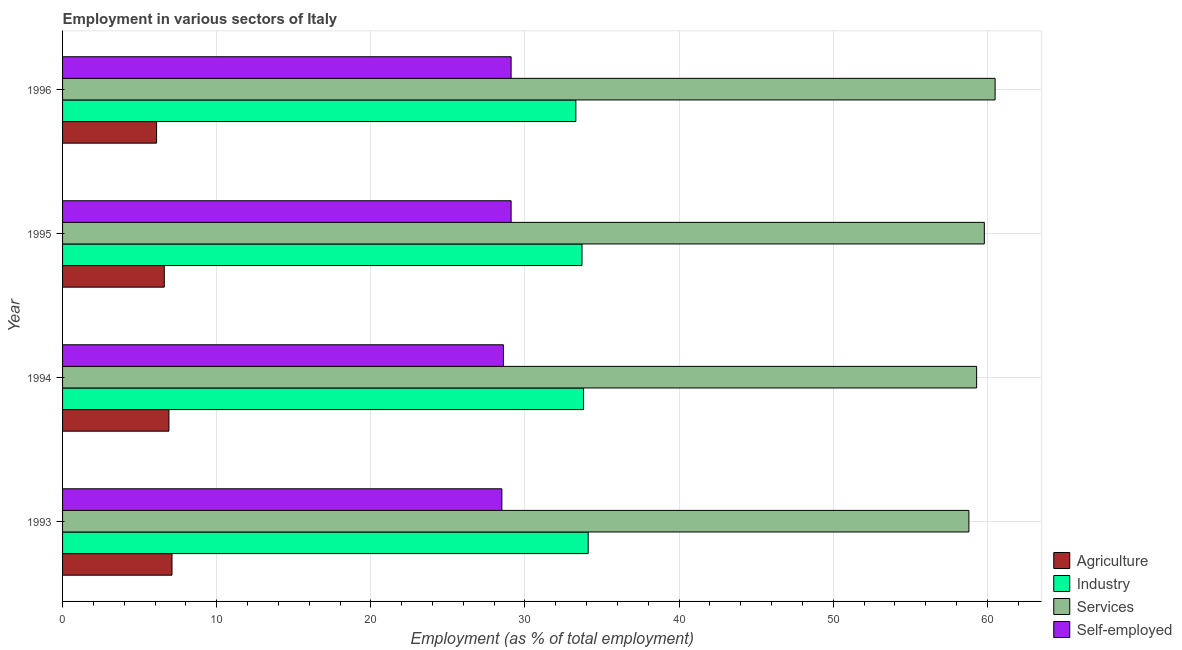How many bars are there on the 4th tick from the top?
Offer a very short reply. 4. How many bars are there on the 1st tick from the bottom?
Ensure brevity in your answer.  4. What is the label of the 2nd group of bars from the top?
Your answer should be compact. 1995. What is the percentage of workers in services in 1993?
Offer a terse response. 58.8. Across all years, what is the maximum percentage of workers in services?
Your answer should be very brief. 60.5. Across all years, what is the minimum percentage of self employed workers?
Provide a succinct answer. 28.5. In which year was the percentage of workers in industry maximum?
Give a very brief answer. 1993. What is the total percentage of workers in agriculture in the graph?
Your answer should be very brief. 26.7. What is the difference between the percentage of workers in services in 1995 and the percentage of workers in agriculture in 1993?
Offer a terse response. 52.7. What is the average percentage of self employed workers per year?
Make the answer very short. 28.82. In the year 1993, what is the difference between the percentage of workers in industry and percentage of self employed workers?
Give a very brief answer. 5.6. In how many years, is the percentage of workers in services greater than 38 %?
Your answer should be very brief. 4. What is the ratio of the percentage of workers in industry in 1993 to that in 1995?
Your answer should be compact. 1.01. Is the percentage of self employed workers in 1993 less than that in 1994?
Make the answer very short. Yes. Is the difference between the percentage of workers in agriculture in 1995 and 1996 greater than the difference between the percentage of workers in industry in 1995 and 1996?
Your answer should be compact. Yes. What is the difference between the highest and the second highest percentage of workers in services?
Offer a terse response. 0.7. What is the difference between the highest and the lowest percentage of workers in industry?
Ensure brevity in your answer.  0.8. Is the sum of the percentage of self employed workers in 1993 and 1994 greater than the maximum percentage of workers in agriculture across all years?
Provide a short and direct response. Yes. What does the 2nd bar from the top in 1995 represents?
Keep it short and to the point. Services. What does the 3rd bar from the bottom in 1995 represents?
Your response must be concise. Services. How many bars are there?
Provide a succinct answer. 16. How many years are there in the graph?
Your answer should be compact. 4. What is the difference between two consecutive major ticks on the X-axis?
Give a very brief answer. 10. Are the values on the major ticks of X-axis written in scientific E-notation?
Keep it short and to the point. No. Does the graph contain grids?
Your answer should be compact. Yes. How many legend labels are there?
Provide a short and direct response. 4. How are the legend labels stacked?
Offer a very short reply. Vertical. What is the title of the graph?
Offer a very short reply. Employment in various sectors of Italy. What is the label or title of the X-axis?
Keep it short and to the point. Employment (as % of total employment). What is the label or title of the Y-axis?
Keep it short and to the point. Year. What is the Employment (as % of total employment) in Agriculture in 1993?
Make the answer very short. 7.1. What is the Employment (as % of total employment) in Industry in 1993?
Your answer should be compact. 34.1. What is the Employment (as % of total employment) in Services in 1993?
Your response must be concise. 58.8. What is the Employment (as % of total employment) of Self-employed in 1993?
Your answer should be very brief. 28.5. What is the Employment (as % of total employment) in Agriculture in 1994?
Your answer should be compact. 6.9. What is the Employment (as % of total employment) in Industry in 1994?
Your answer should be very brief. 33.8. What is the Employment (as % of total employment) of Services in 1994?
Provide a short and direct response. 59.3. What is the Employment (as % of total employment) of Self-employed in 1994?
Provide a succinct answer. 28.6. What is the Employment (as % of total employment) of Agriculture in 1995?
Your response must be concise. 6.6. What is the Employment (as % of total employment) of Industry in 1995?
Your answer should be compact. 33.7. What is the Employment (as % of total employment) of Services in 1995?
Your answer should be compact. 59.8. What is the Employment (as % of total employment) in Self-employed in 1995?
Your answer should be very brief. 29.1. What is the Employment (as % of total employment) of Agriculture in 1996?
Give a very brief answer. 6.1. What is the Employment (as % of total employment) in Industry in 1996?
Give a very brief answer. 33.3. What is the Employment (as % of total employment) of Services in 1996?
Ensure brevity in your answer.  60.5. What is the Employment (as % of total employment) in Self-employed in 1996?
Keep it short and to the point. 29.1. Across all years, what is the maximum Employment (as % of total employment) in Agriculture?
Keep it short and to the point. 7.1. Across all years, what is the maximum Employment (as % of total employment) in Industry?
Offer a terse response. 34.1. Across all years, what is the maximum Employment (as % of total employment) in Services?
Provide a short and direct response. 60.5. Across all years, what is the maximum Employment (as % of total employment) in Self-employed?
Your response must be concise. 29.1. Across all years, what is the minimum Employment (as % of total employment) in Agriculture?
Your response must be concise. 6.1. Across all years, what is the minimum Employment (as % of total employment) of Industry?
Your response must be concise. 33.3. Across all years, what is the minimum Employment (as % of total employment) in Services?
Give a very brief answer. 58.8. What is the total Employment (as % of total employment) of Agriculture in the graph?
Offer a terse response. 26.7. What is the total Employment (as % of total employment) in Industry in the graph?
Your answer should be very brief. 134.9. What is the total Employment (as % of total employment) in Services in the graph?
Provide a succinct answer. 238.4. What is the total Employment (as % of total employment) in Self-employed in the graph?
Provide a short and direct response. 115.3. What is the difference between the Employment (as % of total employment) in Services in 1993 and that in 1994?
Provide a short and direct response. -0.5. What is the difference between the Employment (as % of total employment) of Services in 1993 and that in 1995?
Ensure brevity in your answer.  -1. What is the difference between the Employment (as % of total employment) in Self-employed in 1993 and that in 1995?
Ensure brevity in your answer.  -0.6. What is the difference between the Employment (as % of total employment) in Agriculture in 1993 and that in 1996?
Give a very brief answer. 1. What is the difference between the Employment (as % of total employment) in Industry in 1993 and that in 1996?
Your answer should be very brief. 0.8. What is the difference between the Employment (as % of total employment) of Services in 1993 and that in 1996?
Offer a very short reply. -1.7. What is the difference between the Employment (as % of total employment) in Self-employed in 1994 and that in 1995?
Your answer should be very brief. -0.5. What is the difference between the Employment (as % of total employment) in Services in 1994 and that in 1996?
Provide a succinct answer. -1.2. What is the difference between the Employment (as % of total employment) of Agriculture in 1995 and that in 1996?
Your response must be concise. 0.5. What is the difference between the Employment (as % of total employment) in Industry in 1995 and that in 1996?
Provide a short and direct response. 0.4. What is the difference between the Employment (as % of total employment) in Agriculture in 1993 and the Employment (as % of total employment) in Industry in 1994?
Offer a terse response. -26.7. What is the difference between the Employment (as % of total employment) in Agriculture in 1993 and the Employment (as % of total employment) in Services in 1994?
Provide a succinct answer. -52.2. What is the difference between the Employment (as % of total employment) in Agriculture in 1993 and the Employment (as % of total employment) in Self-employed in 1994?
Provide a short and direct response. -21.5. What is the difference between the Employment (as % of total employment) in Industry in 1993 and the Employment (as % of total employment) in Services in 1994?
Provide a short and direct response. -25.2. What is the difference between the Employment (as % of total employment) in Industry in 1993 and the Employment (as % of total employment) in Self-employed in 1994?
Make the answer very short. 5.5. What is the difference between the Employment (as % of total employment) of Services in 1993 and the Employment (as % of total employment) of Self-employed in 1994?
Offer a terse response. 30.2. What is the difference between the Employment (as % of total employment) in Agriculture in 1993 and the Employment (as % of total employment) in Industry in 1995?
Provide a succinct answer. -26.6. What is the difference between the Employment (as % of total employment) of Agriculture in 1993 and the Employment (as % of total employment) of Services in 1995?
Keep it short and to the point. -52.7. What is the difference between the Employment (as % of total employment) in Industry in 1993 and the Employment (as % of total employment) in Services in 1995?
Provide a short and direct response. -25.7. What is the difference between the Employment (as % of total employment) of Industry in 1993 and the Employment (as % of total employment) of Self-employed in 1995?
Provide a succinct answer. 5. What is the difference between the Employment (as % of total employment) of Services in 1993 and the Employment (as % of total employment) of Self-employed in 1995?
Give a very brief answer. 29.7. What is the difference between the Employment (as % of total employment) of Agriculture in 1993 and the Employment (as % of total employment) of Industry in 1996?
Ensure brevity in your answer.  -26.2. What is the difference between the Employment (as % of total employment) in Agriculture in 1993 and the Employment (as % of total employment) in Services in 1996?
Your response must be concise. -53.4. What is the difference between the Employment (as % of total employment) of Industry in 1993 and the Employment (as % of total employment) of Services in 1996?
Keep it short and to the point. -26.4. What is the difference between the Employment (as % of total employment) in Industry in 1993 and the Employment (as % of total employment) in Self-employed in 1996?
Offer a very short reply. 5. What is the difference between the Employment (as % of total employment) of Services in 1993 and the Employment (as % of total employment) of Self-employed in 1996?
Make the answer very short. 29.7. What is the difference between the Employment (as % of total employment) in Agriculture in 1994 and the Employment (as % of total employment) in Industry in 1995?
Your answer should be compact. -26.8. What is the difference between the Employment (as % of total employment) in Agriculture in 1994 and the Employment (as % of total employment) in Services in 1995?
Your answer should be very brief. -52.9. What is the difference between the Employment (as % of total employment) of Agriculture in 1994 and the Employment (as % of total employment) of Self-employed in 1995?
Your response must be concise. -22.2. What is the difference between the Employment (as % of total employment) in Industry in 1994 and the Employment (as % of total employment) in Services in 1995?
Make the answer very short. -26. What is the difference between the Employment (as % of total employment) in Industry in 1994 and the Employment (as % of total employment) in Self-employed in 1995?
Your answer should be very brief. 4.7. What is the difference between the Employment (as % of total employment) in Services in 1994 and the Employment (as % of total employment) in Self-employed in 1995?
Keep it short and to the point. 30.2. What is the difference between the Employment (as % of total employment) of Agriculture in 1994 and the Employment (as % of total employment) of Industry in 1996?
Your answer should be very brief. -26.4. What is the difference between the Employment (as % of total employment) of Agriculture in 1994 and the Employment (as % of total employment) of Services in 1996?
Keep it short and to the point. -53.6. What is the difference between the Employment (as % of total employment) of Agriculture in 1994 and the Employment (as % of total employment) of Self-employed in 1996?
Give a very brief answer. -22.2. What is the difference between the Employment (as % of total employment) of Industry in 1994 and the Employment (as % of total employment) of Services in 1996?
Your response must be concise. -26.7. What is the difference between the Employment (as % of total employment) of Services in 1994 and the Employment (as % of total employment) of Self-employed in 1996?
Your answer should be very brief. 30.2. What is the difference between the Employment (as % of total employment) in Agriculture in 1995 and the Employment (as % of total employment) in Industry in 1996?
Ensure brevity in your answer.  -26.7. What is the difference between the Employment (as % of total employment) in Agriculture in 1995 and the Employment (as % of total employment) in Services in 1996?
Offer a very short reply. -53.9. What is the difference between the Employment (as % of total employment) of Agriculture in 1995 and the Employment (as % of total employment) of Self-employed in 1996?
Ensure brevity in your answer.  -22.5. What is the difference between the Employment (as % of total employment) in Industry in 1995 and the Employment (as % of total employment) in Services in 1996?
Keep it short and to the point. -26.8. What is the difference between the Employment (as % of total employment) in Industry in 1995 and the Employment (as % of total employment) in Self-employed in 1996?
Your answer should be very brief. 4.6. What is the difference between the Employment (as % of total employment) in Services in 1995 and the Employment (as % of total employment) in Self-employed in 1996?
Ensure brevity in your answer.  30.7. What is the average Employment (as % of total employment) of Agriculture per year?
Offer a terse response. 6.67. What is the average Employment (as % of total employment) of Industry per year?
Provide a short and direct response. 33.73. What is the average Employment (as % of total employment) in Services per year?
Your answer should be compact. 59.6. What is the average Employment (as % of total employment) of Self-employed per year?
Offer a terse response. 28.82. In the year 1993, what is the difference between the Employment (as % of total employment) of Agriculture and Employment (as % of total employment) of Industry?
Ensure brevity in your answer.  -27. In the year 1993, what is the difference between the Employment (as % of total employment) in Agriculture and Employment (as % of total employment) in Services?
Offer a very short reply. -51.7. In the year 1993, what is the difference between the Employment (as % of total employment) of Agriculture and Employment (as % of total employment) of Self-employed?
Give a very brief answer. -21.4. In the year 1993, what is the difference between the Employment (as % of total employment) of Industry and Employment (as % of total employment) of Services?
Give a very brief answer. -24.7. In the year 1993, what is the difference between the Employment (as % of total employment) in Industry and Employment (as % of total employment) in Self-employed?
Provide a short and direct response. 5.6. In the year 1993, what is the difference between the Employment (as % of total employment) of Services and Employment (as % of total employment) of Self-employed?
Your response must be concise. 30.3. In the year 1994, what is the difference between the Employment (as % of total employment) in Agriculture and Employment (as % of total employment) in Industry?
Provide a short and direct response. -26.9. In the year 1994, what is the difference between the Employment (as % of total employment) of Agriculture and Employment (as % of total employment) of Services?
Provide a succinct answer. -52.4. In the year 1994, what is the difference between the Employment (as % of total employment) of Agriculture and Employment (as % of total employment) of Self-employed?
Make the answer very short. -21.7. In the year 1994, what is the difference between the Employment (as % of total employment) in Industry and Employment (as % of total employment) in Services?
Offer a very short reply. -25.5. In the year 1994, what is the difference between the Employment (as % of total employment) in Industry and Employment (as % of total employment) in Self-employed?
Your response must be concise. 5.2. In the year 1994, what is the difference between the Employment (as % of total employment) in Services and Employment (as % of total employment) in Self-employed?
Give a very brief answer. 30.7. In the year 1995, what is the difference between the Employment (as % of total employment) of Agriculture and Employment (as % of total employment) of Industry?
Your answer should be very brief. -27.1. In the year 1995, what is the difference between the Employment (as % of total employment) of Agriculture and Employment (as % of total employment) of Services?
Make the answer very short. -53.2. In the year 1995, what is the difference between the Employment (as % of total employment) in Agriculture and Employment (as % of total employment) in Self-employed?
Provide a succinct answer. -22.5. In the year 1995, what is the difference between the Employment (as % of total employment) in Industry and Employment (as % of total employment) in Services?
Ensure brevity in your answer.  -26.1. In the year 1995, what is the difference between the Employment (as % of total employment) in Services and Employment (as % of total employment) in Self-employed?
Keep it short and to the point. 30.7. In the year 1996, what is the difference between the Employment (as % of total employment) in Agriculture and Employment (as % of total employment) in Industry?
Make the answer very short. -27.2. In the year 1996, what is the difference between the Employment (as % of total employment) of Agriculture and Employment (as % of total employment) of Services?
Your answer should be very brief. -54.4. In the year 1996, what is the difference between the Employment (as % of total employment) in Agriculture and Employment (as % of total employment) in Self-employed?
Give a very brief answer. -23. In the year 1996, what is the difference between the Employment (as % of total employment) of Industry and Employment (as % of total employment) of Services?
Make the answer very short. -27.2. In the year 1996, what is the difference between the Employment (as % of total employment) of Services and Employment (as % of total employment) of Self-employed?
Offer a terse response. 31.4. What is the ratio of the Employment (as % of total employment) of Agriculture in 1993 to that in 1994?
Make the answer very short. 1.03. What is the ratio of the Employment (as % of total employment) of Industry in 1993 to that in 1994?
Offer a very short reply. 1.01. What is the ratio of the Employment (as % of total employment) of Services in 1993 to that in 1994?
Provide a succinct answer. 0.99. What is the ratio of the Employment (as % of total employment) in Agriculture in 1993 to that in 1995?
Keep it short and to the point. 1.08. What is the ratio of the Employment (as % of total employment) in Industry in 1993 to that in 1995?
Give a very brief answer. 1.01. What is the ratio of the Employment (as % of total employment) in Services in 1993 to that in 1995?
Give a very brief answer. 0.98. What is the ratio of the Employment (as % of total employment) in Self-employed in 1993 to that in 1995?
Ensure brevity in your answer.  0.98. What is the ratio of the Employment (as % of total employment) in Agriculture in 1993 to that in 1996?
Your answer should be compact. 1.16. What is the ratio of the Employment (as % of total employment) in Services in 1993 to that in 1996?
Provide a succinct answer. 0.97. What is the ratio of the Employment (as % of total employment) in Self-employed in 1993 to that in 1996?
Your response must be concise. 0.98. What is the ratio of the Employment (as % of total employment) in Agriculture in 1994 to that in 1995?
Offer a terse response. 1.05. What is the ratio of the Employment (as % of total employment) of Industry in 1994 to that in 1995?
Make the answer very short. 1. What is the ratio of the Employment (as % of total employment) in Services in 1994 to that in 1995?
Offer a very short reply. 0.99. What is the ratio of the Employment (as % of total employment) of Self-employed in 1994 to that in 1995?
Ensure brevity in your answer.  0.98. What is the ratio of the Employment (as % of total employment) of Agriculture in 1994 to that in 1996?
Your answer should be compact. 1.13. What is the ratio of the Employment (as % of total employment) of Industry in 1994 to that in 1996?
Offer a very short reply. 1.01. What is the ratio of the Employment (as % of total employment) of Services in 1994 to that in 1996?
Make the answer very short. 0.98. What is the ratio of the Employment (as % of total employment) in Self-employed in 1994 to that in 1996?
Provide a succinct answer. 0.98. What is the ratio of the Employment (as % of total employment) of Agriculture in 1995 to that in 1996?
Ensure brevity in your answer.  1.08. What is the ratio of the Employment (as % of total employment) in Industry in 1995 to that in 1996?
Your response must be concise. 1.01. What is the ratio of the Employment (as % of total employment) of Services in 1995 to that in 1996?
Ensure brevity in your answer.  0.99. What is the ratio of the Employment (as % of total employment) in Self-employed in 1995 to that in 1996?
Your answer should be compact. 1. What is the difference between the highest and the second highest Employment (as % of total employment) of Agriculture?
Your answer should be very brief. 0.2. What is the difference between the highest and the second highest Employment (as % of total employment) of Self-employed?
Provide a short and direct response. 0. What is the difference between the highest and the lowest Employment (as % of total employment) in Agriculture?
Offer a terse response. 1. What is the difference between the highest and the lowest Employment (as % of total employment) of Services?
Your answer should be very brief. 1.7. 